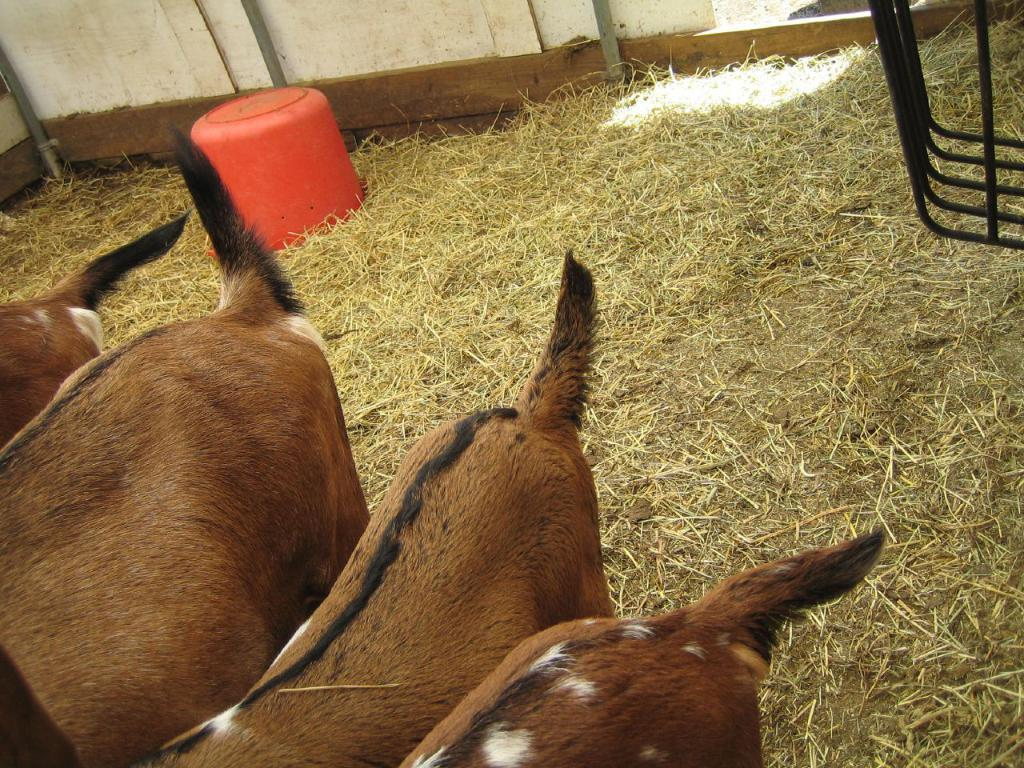What can be seen in the background of the image? There is a wall in the background of the image. What types of objects are present in the image? There are objects in the image, but their specific details are not mentioned. What type of vegetation is present in the image? Dried grass is present in the image. What color is the tub visible in the image? There is a red tub in the image. What part of animals can be seen in the image? A partial part of animals is visible in the image. What type of attraction can be seen in the image? There is no attraction present in the image; it only features a wall, objects, dried grass, a red tub, and a partial part of animals. What season is depicted in the image? The provided facts do not mention any seasonal elements, so it cannot be determined from the image. 